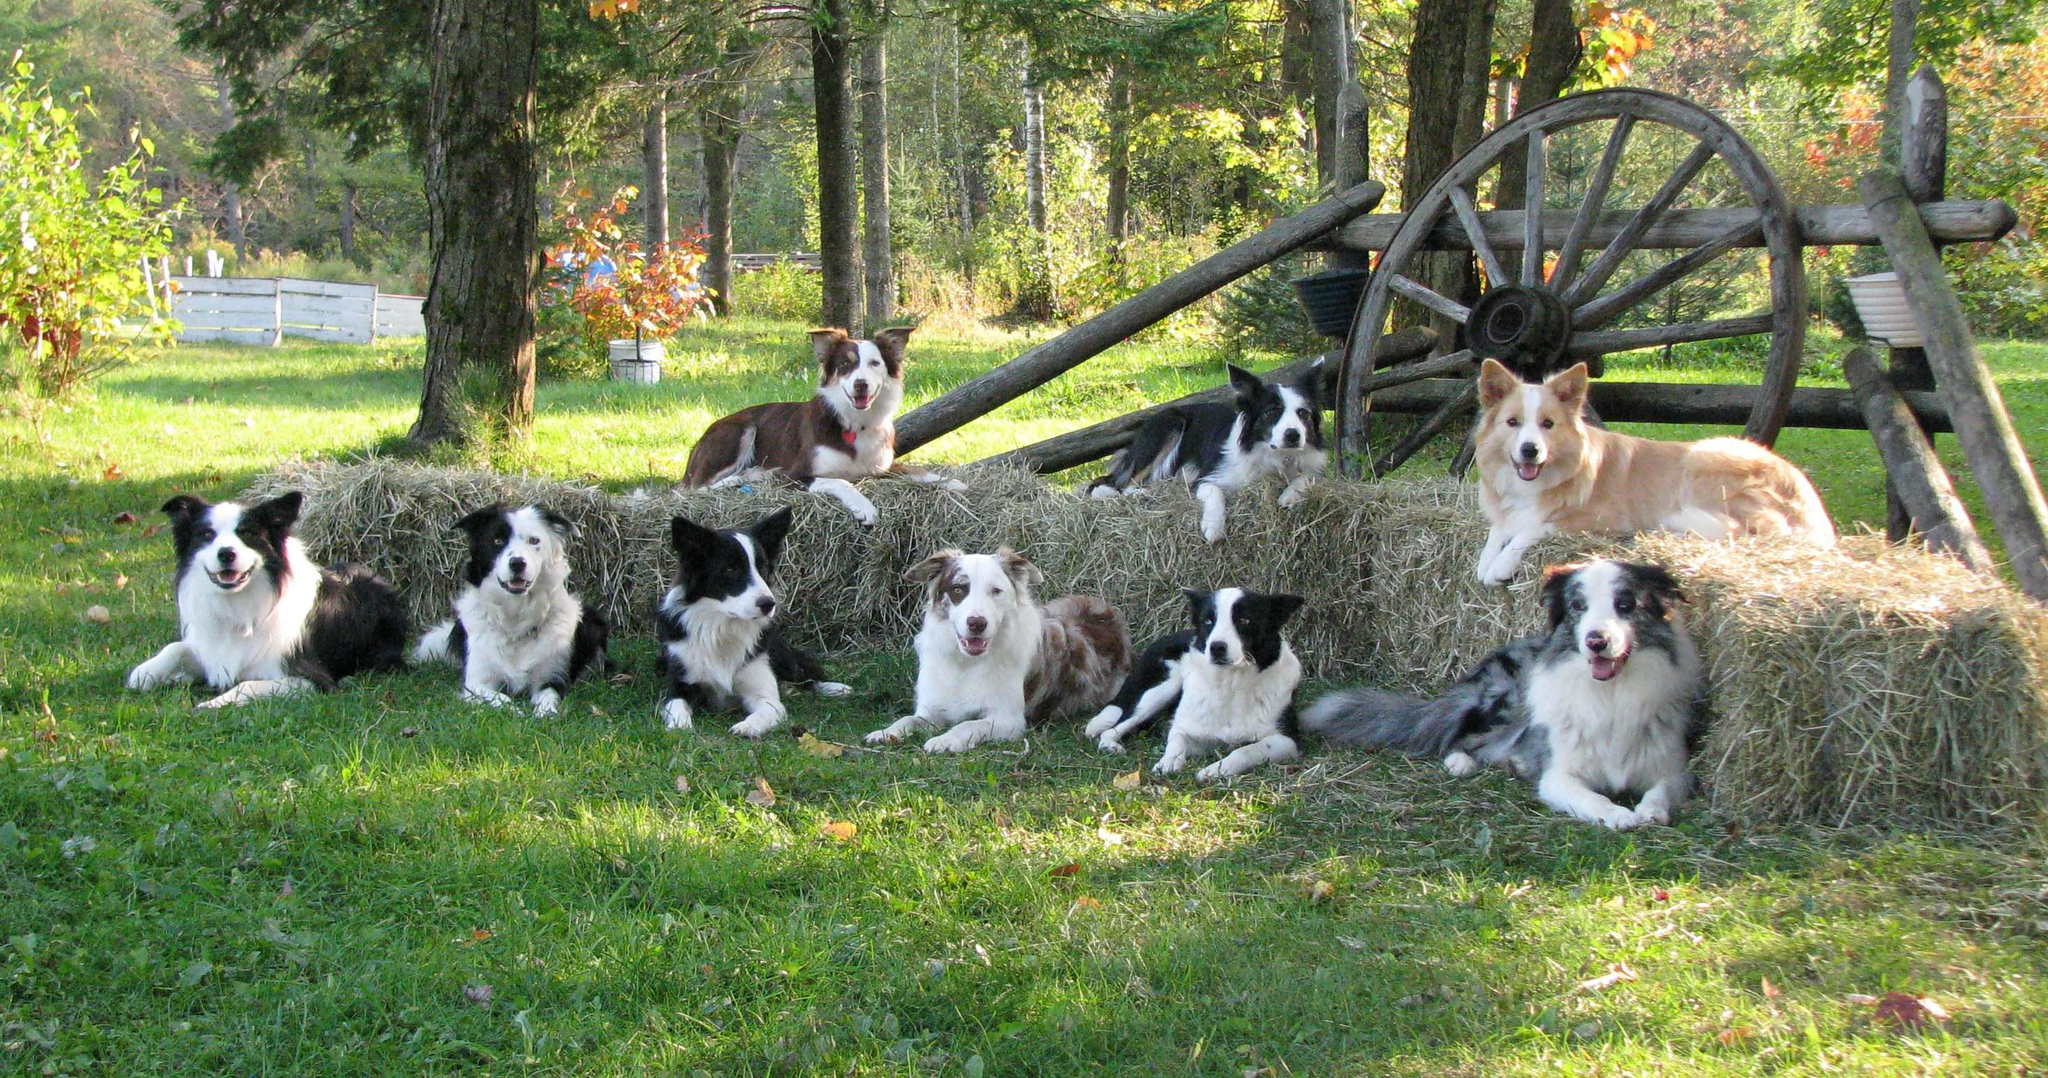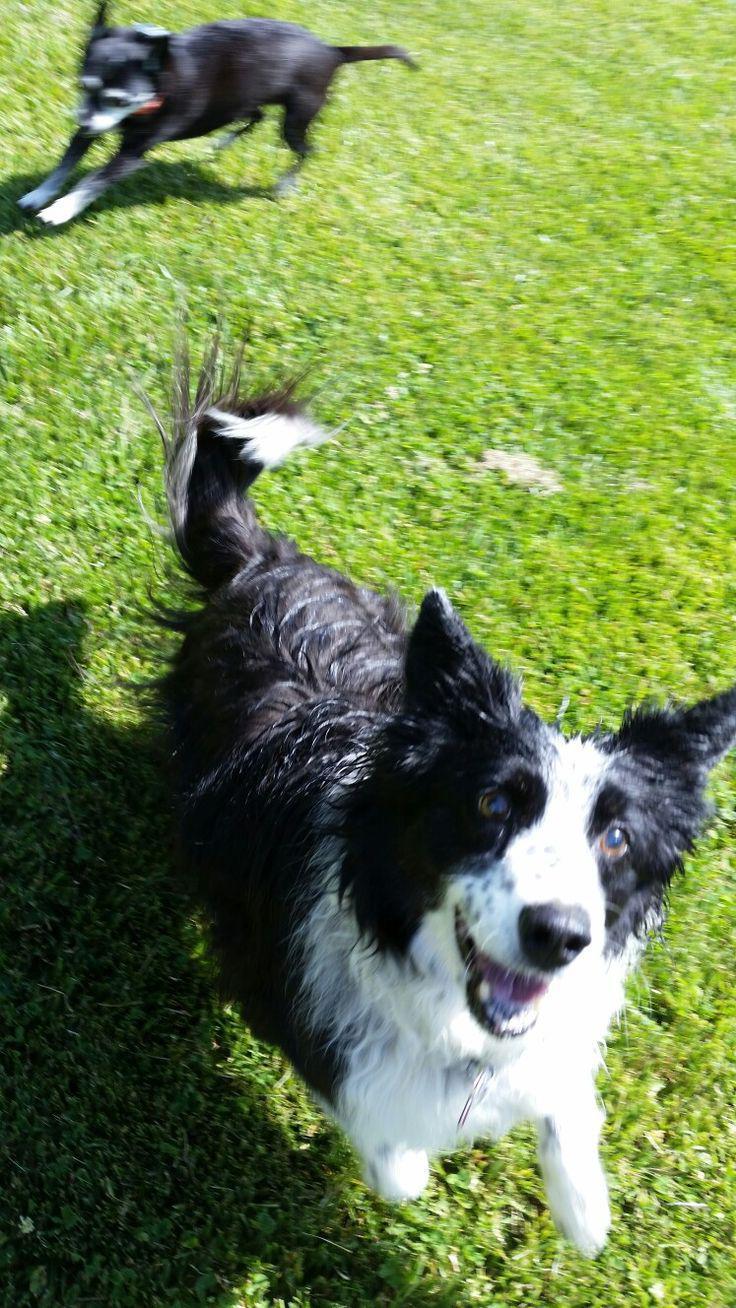The first image is the image on the left, the second image is the image on the right. Considering the images on both sides, is "One image includes a dog running toward the camera, and the other image shows reclining dogs, with some kind of heaped plant material in a horizontal row." valid? Answer yes or no. Yes. The first image is the image on the left, the second image is the image on the right. Analyze the images presented: Is the assertion "There are more dogs in the image on the right." valid? Answer yes or no. No. 